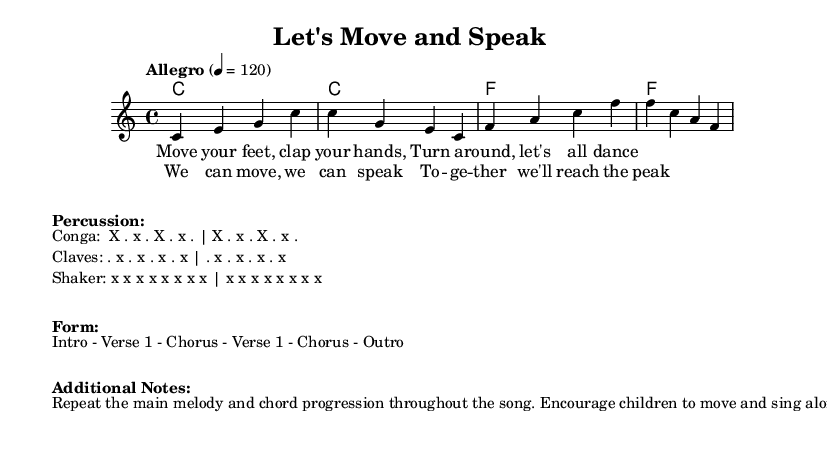What is the key signature of this music? The key signature is C major, which has no sharps or flats.
Answer: C major What is the time signature of this piece? The time signature, which indicates how the beats are organized, is found at the beginning of the music, showing there are four beats per measure.
Answer: 4/4 What is the tempo marking for this piece? The tempo marking indicates the speed of the music, marked as "Allegro," which translates to fast or lively, further specified by the beats per minute.
Answer: Allegro 4 = 120 What is the first line of the verse lyrics? The first line of the verse can be identified by examining the lyric mode section, where it starts with the command to move.
Answer: Move your feet, clap your hands How many measures are in the chorus section? To answer this, count the measures in the chorus lyric section, which corresponds to the musical phrasing presented.
Answer: 2 What kind of rhythm is suggested for the shaker? Look in the percussion section where the pattern for the shaker is specified, indicating a continuous rhythm.
Answer: x x x x x x x x How is call-and-response utilized in the song? This question requires synthesizing the verse lyrics and structure, observing that it involves repeating phrases for children to echo, enhancing interaction and speech practice.
Answer: Repeating phrases 